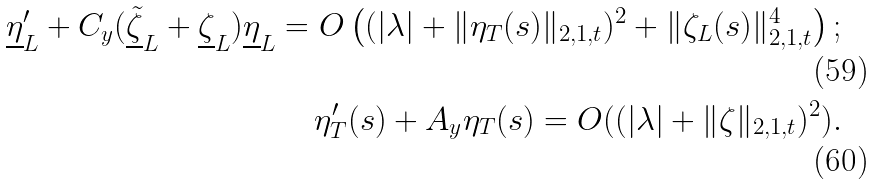<formula> <loc_0><loc_0><loc_500><loc_500>\underline { \eta } _ { L } ^ { \prime } + C _ { y } ( \underline { \tilde { \zeta } } _ { L } + \underline { \zeta } _ { L } ) \underline { \eta } _ { L } = O \left ( ( | \lambda | + \| \eta _ { T } ( s ) \| _ { 2 , 1 , t } ) ^ { 2 } + \| \zeta _ { L } ( s ) \| _ { 2 , 1 , t } ^ { 4 } \right ) ; \\ \eta _ { T } ^ { \prime } ( s ) + A _ { y } \eta _ { T } ( s ) = O ( ( | \lambda | + \| \zeta \| _ { 2 , 1 , t } ) ^ { 2 } ) .</formula> 